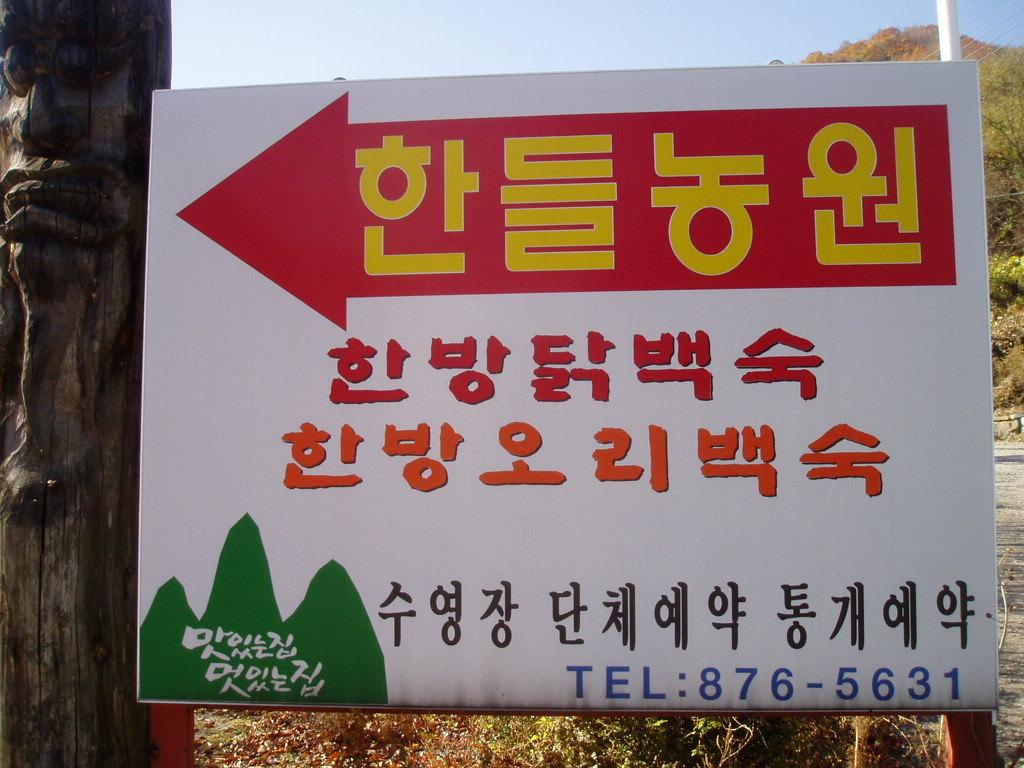What is located in the center of the image? There is a sign board in the center of the image. What can be seen in the background of the image? There are trees in the background of the image. What type of lumber is being used to support the sign board in the image? There is no indication of the type of lumber used to support the sign board in the image. What is the weight of the rock that is visible in the image? There is no rock visible in the image. 